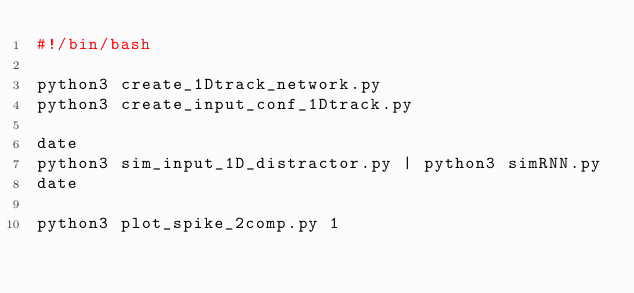Convert code to text. <code><loc_0><loc_0><loc_500><loc_500><_Bash_>#!/bin/bash

python3 create_1Dtrack_network.py
python3 create_input_conf_1Dtrack.py

date
python3 sim_input_1D_distractor.py | python3 simRNN.py
date

python3 plot_spike_2comp.py 1
</code> 